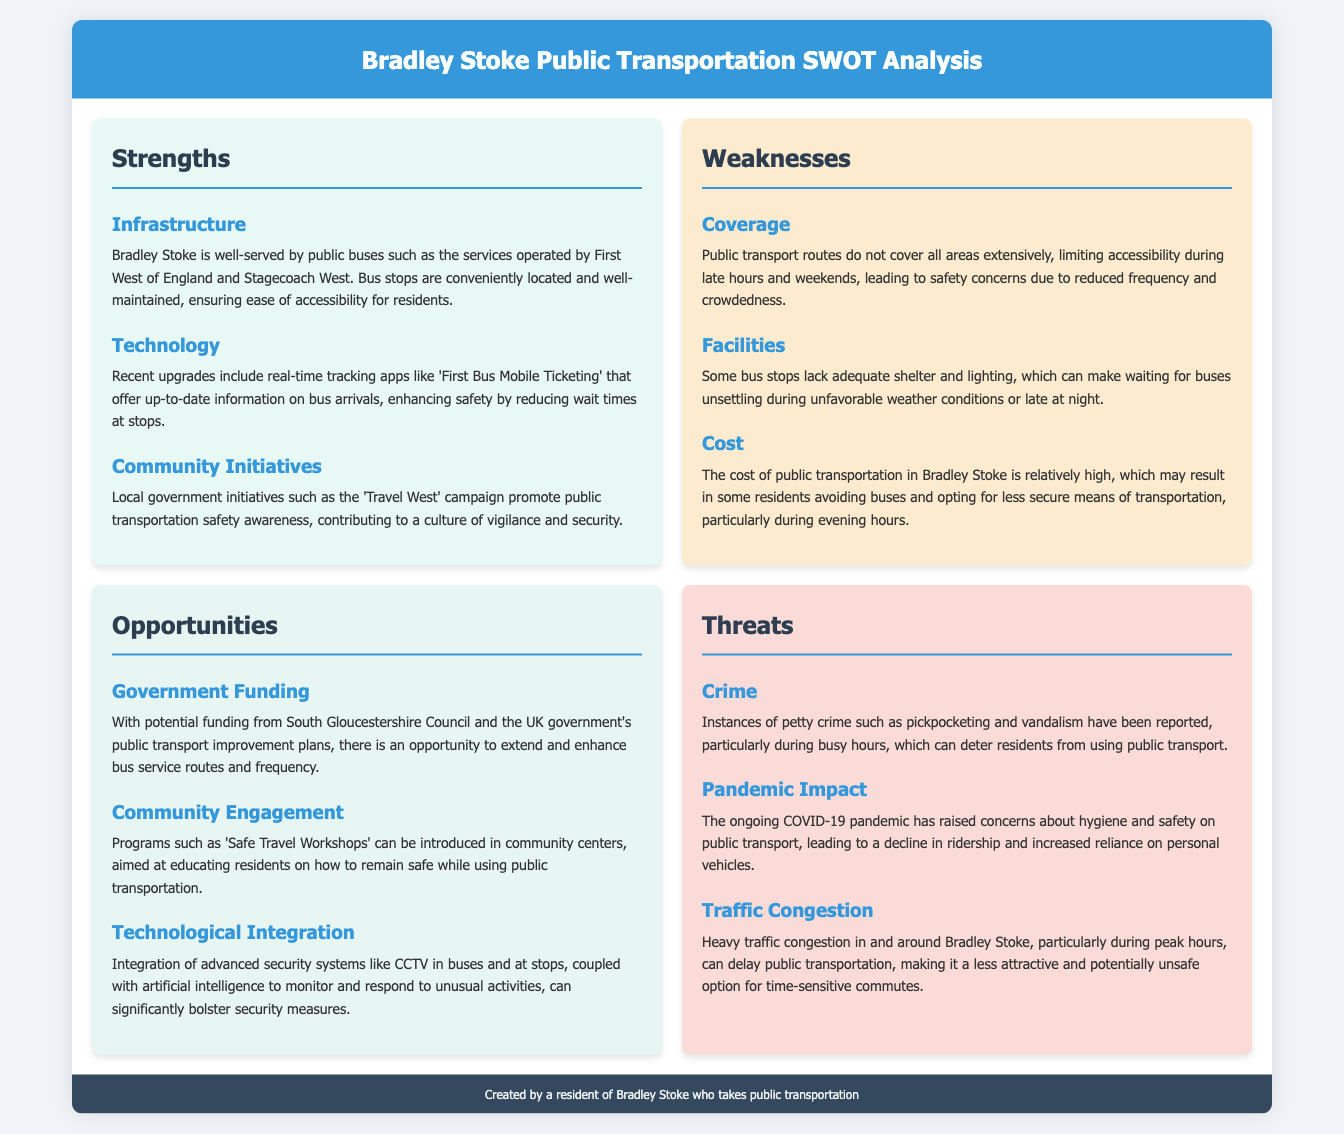What public transport services are mentioned? The public transport services mentioned are operated by First West of England and Stagecoach West.
Answer: First West of England and Stagecoach West What enhances safety by reducing wait times? The real-time tracking apps like 'First Bus Mobile Ticketing' enhance safety by reducing wait times at stops.
Answer: Real-time tracking apps Which campaign promotes public transportation safety awareness? The 'Travel West' campaign promotes public transportation safety awareness in Bradley Stoke.
Answer: Travel West What is identified as a weakness related to bus stops? Some bus stops lack adequate shelter and lighting.
Answer: Shelter and lighting What government initiative could improve bus services? Potential funding from South Gloucestershire Council could improve bus services.
Answer: South Gloucestershire Council What type of workshops could educate residents on safety? 'Safe Travel Workshops' could be introduced to educate residents on safety while using public transportation.
Answer: Safe Travel Workshops What is a reported crime issue affecting public transportation? Instances of petty crime such as pickpocketing and vandalism are reported affecting public transportation.
Answer: Petty crime What impact has the COVID-19 pandemic had on public transportation? The ongoing COVID-19 pandemic has raised concerns about hygiene and safety on public transport.
Answer: Hygiene and safety concerns What could be integrated for better security measures? The integration of advanced security systems like CCTV could bolster security measures.
Answer: CCTV 